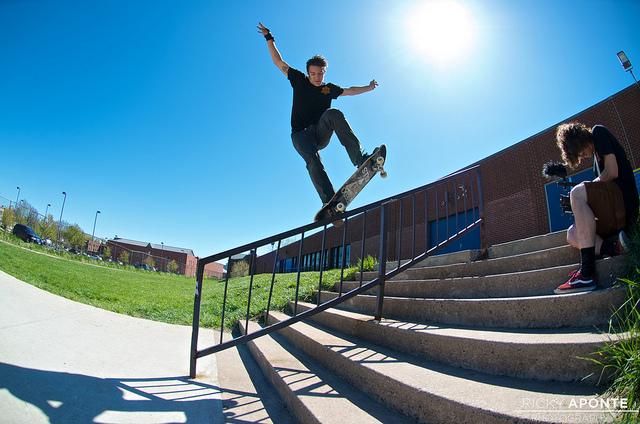How many steps are there?
Answer briefly. 7. Is anyone looking at the skater?
Be succinct. No. What sport is this?
Write a very short answer. Skateboarding. What color is the dirt?
Answer briefly. Brown. How many steps are in this scene?
Quick response, please. 7. 